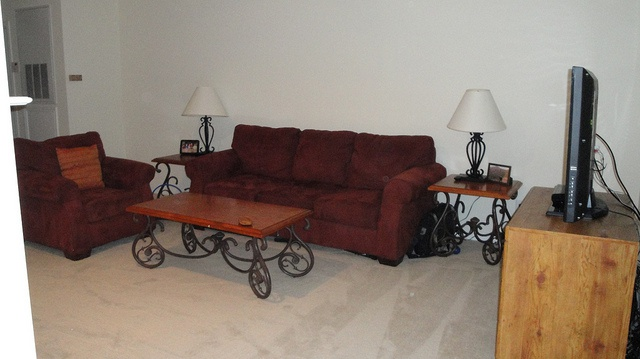Describe the objects in this image and their specific colors. I can see couch in darkgray, black, maroon, and gray tones, couch in darkgray, black, maroon, and gray tones, chair in darkgray, black, maroon, and gray tones, tv in darkgray, black, and gray tones, and backpack in darkgray, black, and gray tones in this image. 